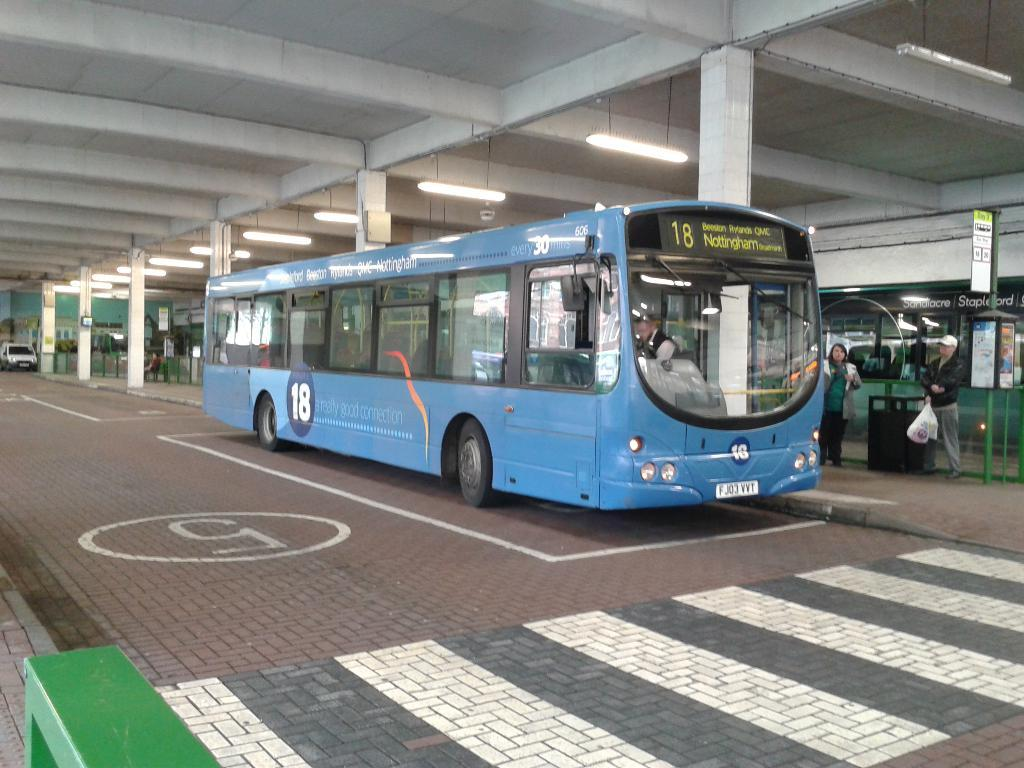<image>
Relay a brief, clear account of the picture shown. A blue bus number 18 is going to Nottingham. 